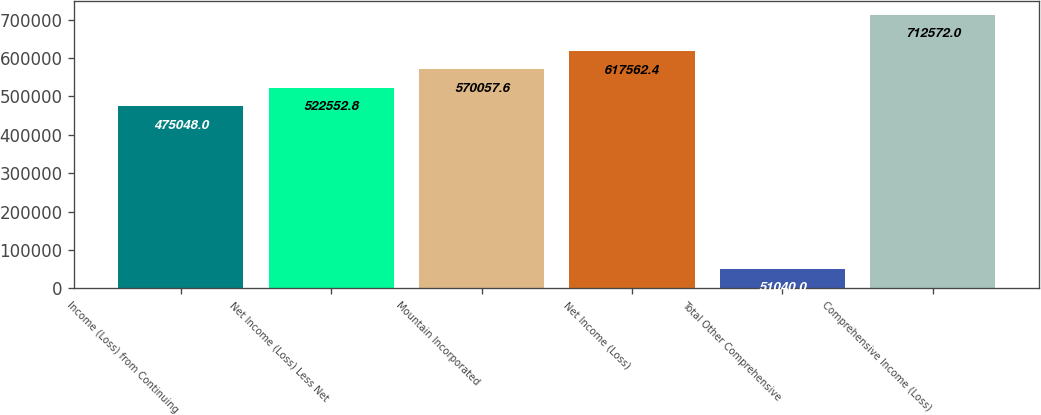Convert chart. <chart><loc_0><loc_0><loc_500><loc_500><bar_chart><fcel>Income (Loss) from Continuing<fcel>Net Income (Loss) Less Net<fcel>Mountain Incorporated<fcel>Net Income (Loss)<fcel>Total Other Comprehensive<fcel>Comprehensive Income (Loss)<nl><fcel>475048<fcel>522553<fcel>570058<fcel>617562<fcel>51040<fcel>712572<nl></chart> 